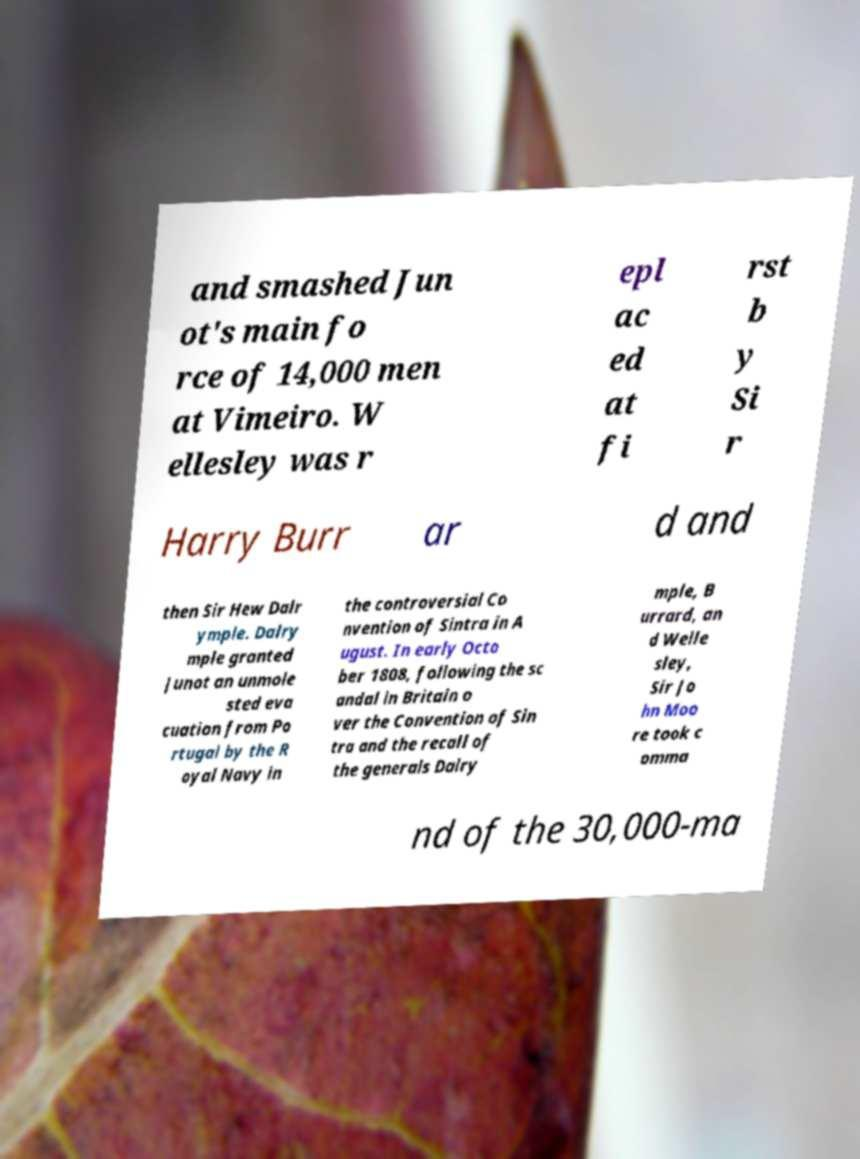For documentation purposes, I need the text within this image transcribed. Could you provide that? and smashed Jun ot's main fo rce of 14,000 men at Vimeiro. W ellesley was r epl ac ed at fi rst b y Si r Harry Burr ar d and then Sir Hew Dalr ymple. Dalry mple granted Junot an unmole sted eva cuation from Po rtugal by the R oyal Navy in the controversial Co nvention of Sintra in A ugust. In early Octo ber 1808, following the sc andal in Britain o ver the Convention of Sin tra and the recall of the generals Dalry mple, B urrard, an d Welle sley, Sir Jo hn Moo re took c omma nd of the 30,000-ma 